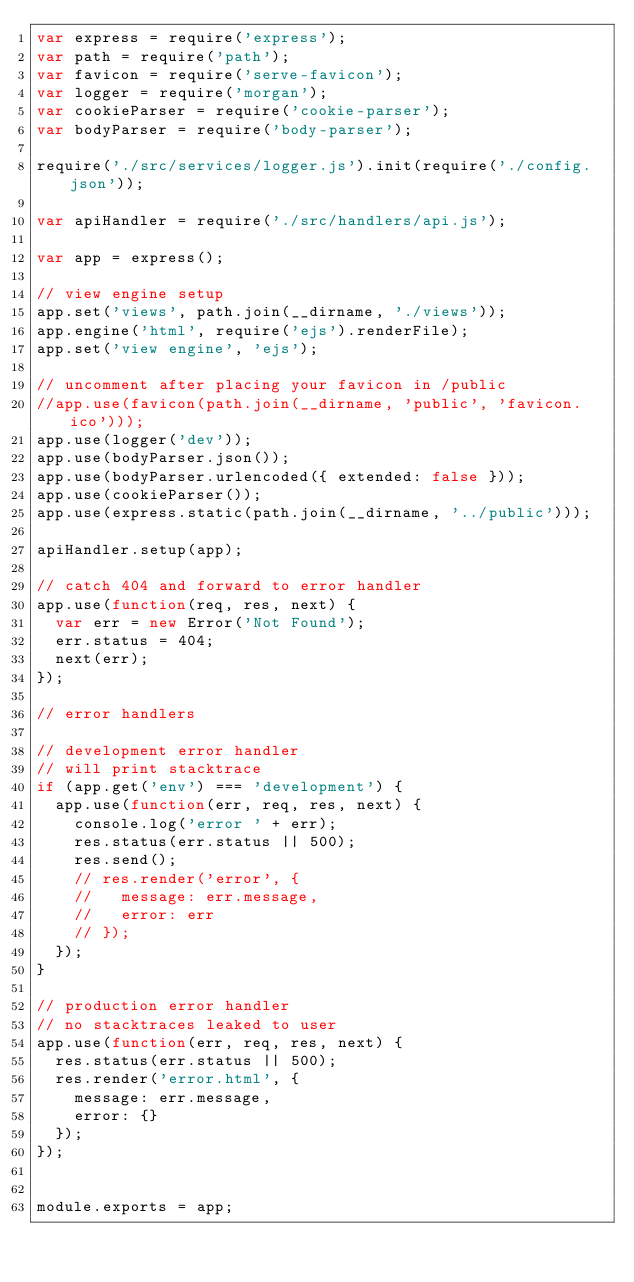<code> <loc_0><loc_0><loc_500><loc_500><_JavaScript_>var express = require('express');
var path = require('path');
var favicon = require('serve-favicon');
var logger = require('morgan');
var cookieParser = require('cookie-parser');
var bodyParser = require('body-parser');

require('./src/services/logger.js').init(require('./config.json'));

var apiHandler = require('./src/handlers/api.js');

var app = express();

// view engine setup
app.set('views', path.join(__dirname, './views'));
app.engine('html', require('ejs').renderFile);
app.set('view engine', 'ejs');

// uncomment after placing your favicon in /public
//app.use(favicon(path.join(__dirname, 'public', 'favicon.ico')));
app.use(logger('dev'));
app.use(bodyParser.json());
app.use(bodyParser.urlencoded({ extended: false }));
app.use(cookieParser());
app.use(express.static(path.join(__dirname, '../public')));

apiHandler.setup(app);

// catch 404 and forward to error handler
app.use(function(req, res, next) {
  var err = new Error('Not Found');
  err.status = 404;
  next(err);
});

// error handlers

// development error handler
// will print stacktrace
if (app.get('env') === 'development') {
  app.use(function(err, req, res, next) {
    console.log('error ' + err);
    res.status(err.status || 500);
    res.send();
    // res.render('error', {
    //   message: err.message,
    //   error: err
    // });
  });
}

// production error handler
// no stacktraces leaked to user
app.use(function(err, req, res, next) {
  res.status(err.status || 500);
  res.render('error.html', {
    message: err.message,
    error: {}
  });
});


module.exports = app;</code> 